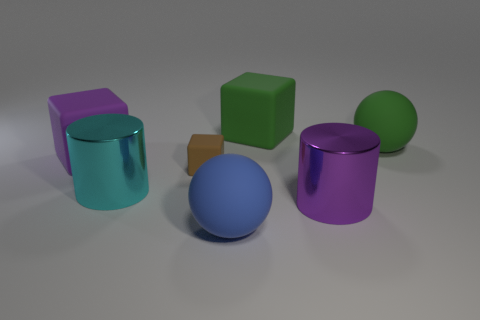What is the color of the other big rubber thing that is the same shape as the blue rubber object?
Provide a succinct answer. Green. Is there anything else that is the same shape as the small object?
Give a very brief answer. Yes. Does the metal object right of the cyan metal cylinder have the same color as the small thing?
Your answer should be very brief. No. The green thing that is the same shape as the brown thing is what size?
Your answer should be very brief. Large. How many yellow cylinders have the same material as the cyan cylinder?
Your response must be concise. 0. There is a shiny object that is left of the large green object on the left side of the large green matte ball; are there any large green matte blocks to the right of it?
Offer a terse response. Yes. The small rubber thing is what shape?
Make the answer very short. Cube. Is the material of the big purple object that is left of the small brown block the same as the cube that is right of the large blue rubber thing?
Give a very brief answer. Yes. What number of big rubber objects are the same color as the small rubber cube?
Ensure brevity in your answer.  0. The thing that is both to the left of the purple metallic cylinder and to the right of the blue rubber thing has what shape?
Give a very brief answer. Cube. 